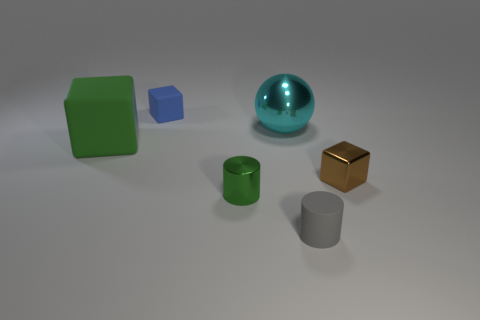Subtract all small blue cubes. How many cubes are left? 2 Add 2 green cubes. How many objects exist? 8 Subtract all green cylinders. How many cylinders are left? 1 Subtract 2 blocks. How many blocks are left? 1 Subtract all brown cylinders. How many green blocks are left? 1 Add 6 small metal things. How many small metal things are left? 8 Add 1 tiny shiny cylinders. How many tiny shiny cylinders exist? 2 Subtract 1 brown cubes. How many objects are left? 5 Subtract all cylinders. How many objects are left? 4 Subtract all red blocks. Subtract all green spheres. How many blocks are left? 3 